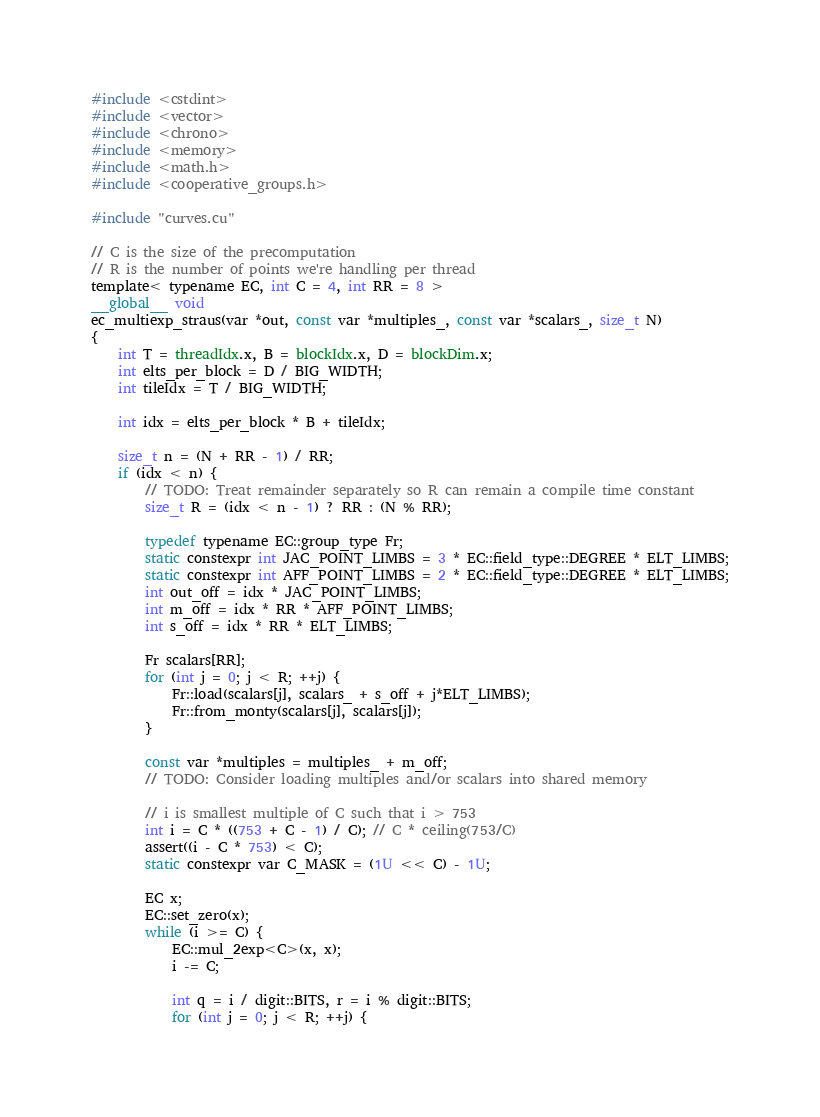Convert code to text. <code><loc_0><loc_0><loc_500><loc_500><_Cuda_>#include <cstdint>
#include <vector>
#include <chrono>
#include <memory>
#include <math.h> 
#include <cooperative_groups.h>

#include "curves.cu"

// C is the size of the precomputation
// R is the number of points we're handling per thread
template< typename EC, int C = 4, int RR = 8 >
__global__ void
ec_multiexp_straus(var *out, const var *multiples_, const var *scalars_, size_t N)
{
    int T = threadIdx.x, B = blockIdx.x, D = blockDim.x;
    int elts_per_block = D / BIG_WIDTH;
    int tileIdx = T / BIG_WIDTH;

    int idx = elts_per_block * B + tileIdx;

    size_t n = (N + RR - 1) / RR;
    if (idx < n) {
        // TODO: Treat remainder separately so R can remain a compile time constant
        size_t R = (idx < n - 1) ? RR : (N % RR);

        typedef typename EC::group_type Fr;
        static constexpr int JAC_POINT_LIMBS = 3 * EC::field_type::DEGREE * ELT_LIMBS;
        static constexpr int AFF_POINT_LIMBS = 2 * EC::field_type::DEGREE * ELT_LIMBS;
        int out_off = idx * JAC_POINT_LIMBS;
        int m_off = idx * RR * AFF_POINT_LIMBS;
        int s_off = idx * RR * ELT_LIMBS;

        Fr scalars[RR];
        for (int j = 0; j < R; ++j) {
            Fr::load(scalars[j], scalars_ + s_off + j*ELT_LIMBS);
            Fr::from_monty(scalars[j], scalars[j]);
        }

        const var *multiples = multiples_ + m_off;
        // TODO: Consider loading multiples and/or scalars into shared memory

        // i is smallest multiple of C such that i > 753
        int i = C * ((753 + C - 1) / C); // C * ceiling(753/C)
        assert((i - C * 753) < C);
        static constexpr var C_MASK = (1U << C) - 1U;

        EC x;
        EC::set_zero(x);
        while (i >= C) {
            EC::mul_2exp<C>(x, x);
            i -= C;

            int q = i / digit::BITS, r = i % digit::BITS;
            for (int j = 0; j < R; ++j) {</code> 